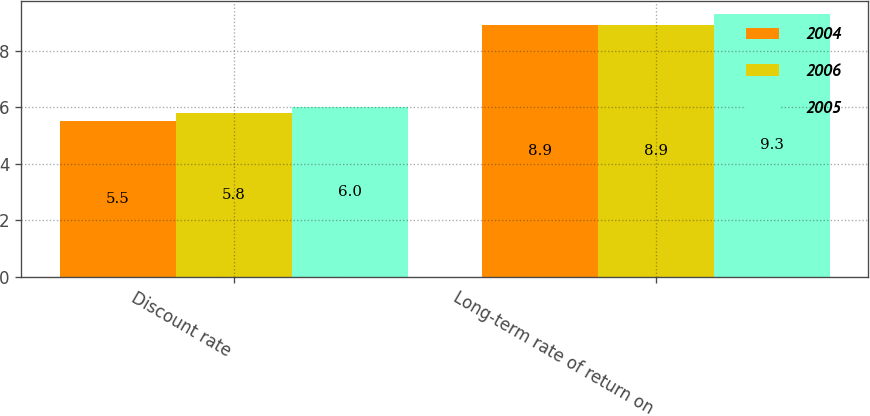Convert chart. <chart><loc_0><loc_0><loc_500><loc_500><stacked_bar_chart><ecel><fcel>Discount rate<fcel>Long-term rate of return on<nl><fcel>2004<fcel>5.5<fcel>8.9<nl><fcel>2006<fcel>5.8<fcel>8.9<nl><fcel>2005<fcel>6<fcel>9.3<nl></chart> 